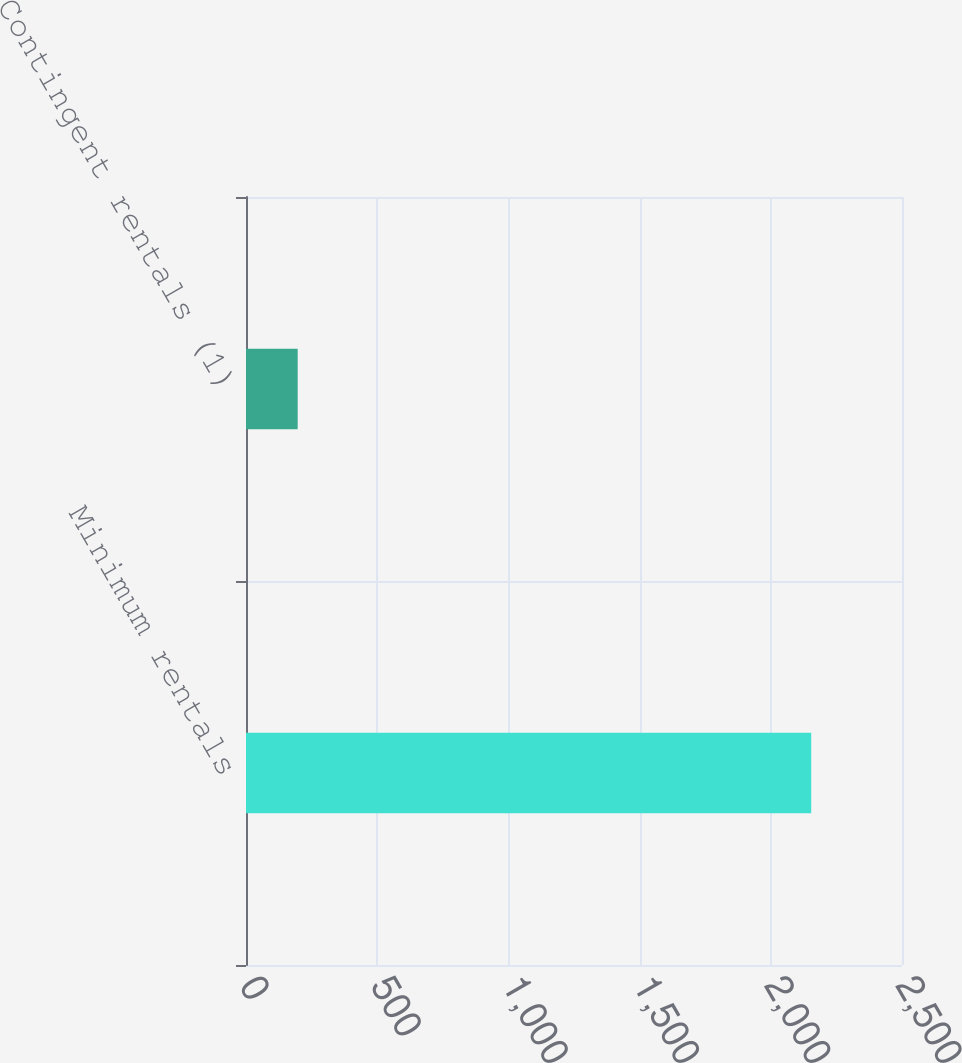<chart> <loc_0><loc_0><loc_500><loc_500><bar_chart><fcel>Minimum rentals<fcel>Contingent rentals (1)<nl><fcel>2154<fcel>197<nl></chart> 